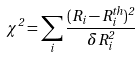<formula> <loc_0><loc_0><loc_500><loc_500>\chi ^ { 2 } = \sum _ { i } \frac { ( R _ { i } - R _ { i } ^ { t h } ) ^ { 2 } } { \delta R _ { i } ^ { 2 } }</formula> 